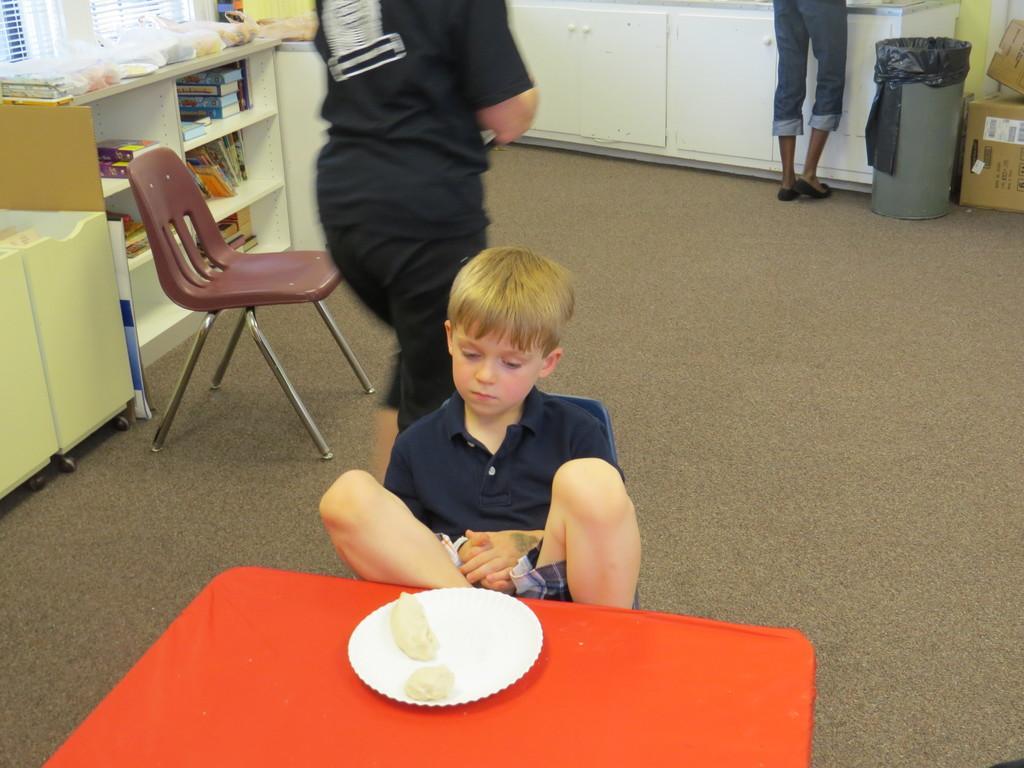Can you describe this image briefly? In this picture there is a boy who is sitting on a chair. There is a paper plate, food. There is a table, chair, books in the shelf and few other objects on the table. There is a bin , boxes. There are two people standing. There is a cupboard. 